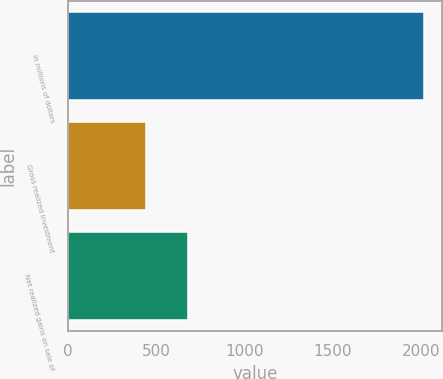Convert chart to OTSL. <chart><loc_0><loc_0><loc_500><loc_500><bar_chart><fcel>In millions of dollars<fcel>Gross realized investment<fcel>Net realized gains on sale of<nl><fcel>2015<fcel>442<fcel>682<nl></chart> 